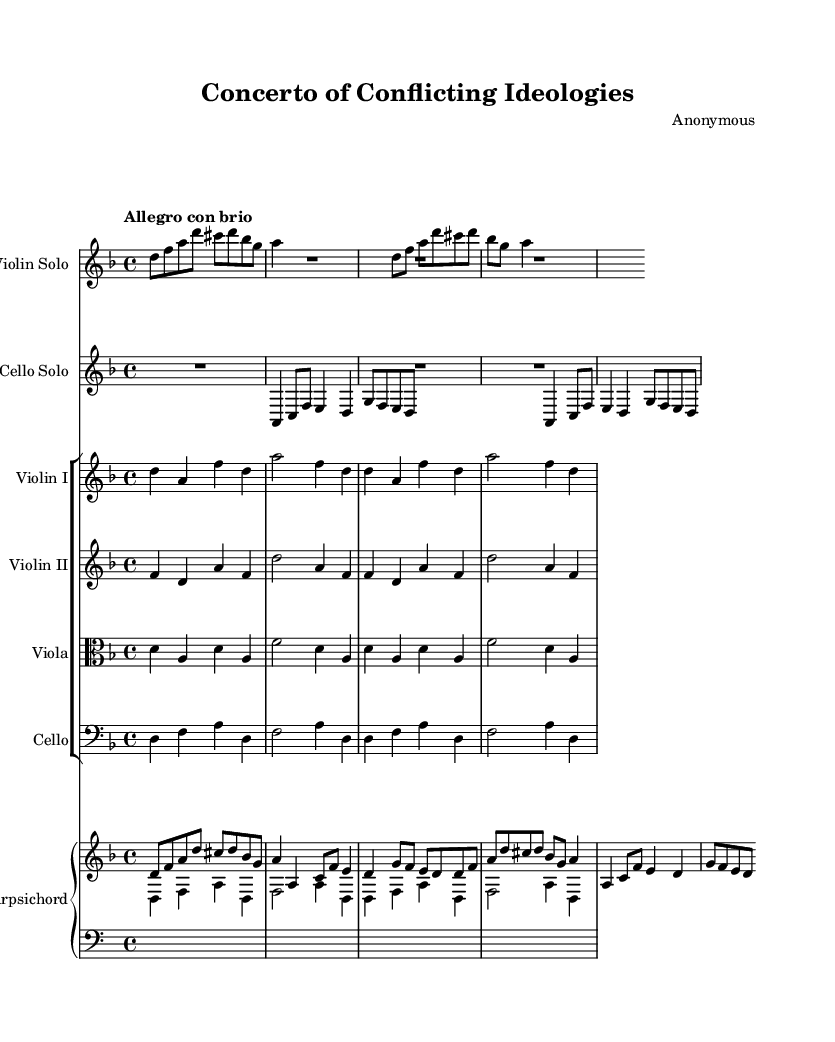What is the key signature of this music? The key signature is D minor, which has one flat (B flat). This can be determined by looking at the key signature indicated at the beginning of the staff, which shows the flat symbol on the B line.
Answer: D minor What is the time signature of this music? The time signature is 4/4, which can be seen at the beginning of the score. This indicates that there are four beats in each measure and a quarter note receives one beat.
Answer: 4/4 What is the tempo marking of this piece? The tempo marking is "Allegro con brio." This is written above the staff, indicating a lively and cheerful pace, suggesting a fast tempo.
Answer: Allegro con brio How many solo instruments are featured in this concerto? There are two solo instruments featured: the violin and the cello. This is indicated by separate staffs for the violin solo and cello solo.
Answer: Two Which instrument plays the harmonizing lower parts throughout the piece? The harpsichord plays the harmonizing lower parts, as indicated in the score where it accompanies the solo instruments. It is typically used in Baroque concertos for this purpose.
Answer: Harpsichord What is the mood conveyed in the violin solo part compared to the cello solo part? The violin solo conveys a more energetic and bright mood, while the cello solo has a deeper, more contemplative character. This represents the contrasting viewpoints in political debates, showcasing conflict and resolution.
Answer: Contrasting moods How is the structure of this concerto typical of Baroque music? The structure of the concerto follows a typical Baroque form, consisting of contrasting sections and a dialogue between the soloists and the ensemble. This structure reflects the Baroque emphasis on contrast and interplay among musical ideas.
Answer: Typical Baroque structure 